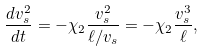<formula> <loc_0><loc_0><loc_500><loc_500>\frac { d v _ { s } ^ { 2 } } { d t } = - \chi _ { 2 } \frac { v _ { s } ^ { 2 } } { \ell / v _ { s } } = - \chi _ { 2 } \frac { v _ { s } ^ { 3 } } { \ell } ,</formula> 